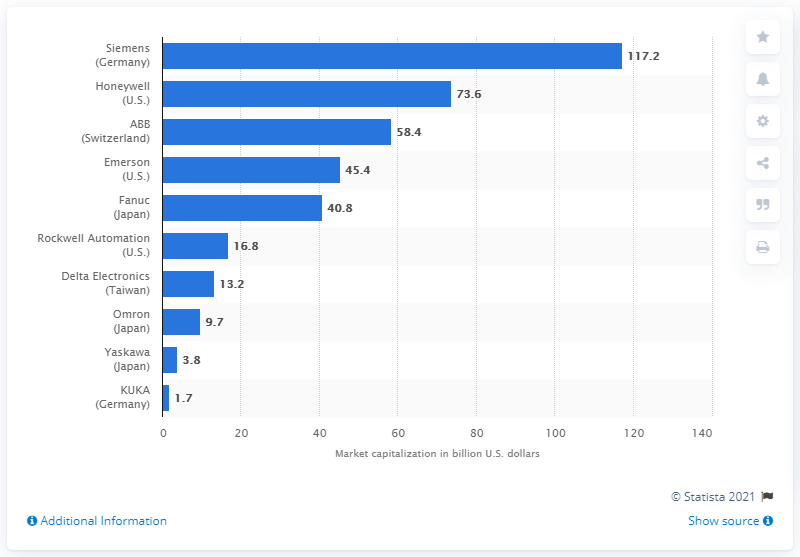Point out several critical features in this image. Rockwell Automation's market capitalization in 2014 was 16.8 billion dollars. 